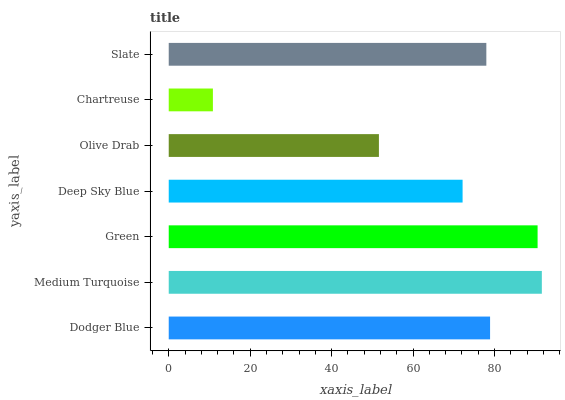Is Chartreuse the minimum?
Answer yes or no. Yes. Is Medium Turquoise the maximum?
Answer yes or no. Yes. Is Green the minimum?
Answer yes or no. No. Is Green the maximum?
Answer yes or no. No. Is Medium Turquoise greater than Green?
Answer yes or no. Yes. Is Green less than Medium Turquoise?
Answer yes or no. Yes. Is Green greater than Medium Turquoise?
Answer yes or no. No. Is Medium Turquoise less than Green?
Answer yes or no. No. Is Slate the high median?
Answer yes or no. Yes. Is Slate the low median?
Answer yes or no. Yes. Is Dodger Blue the high median?
Answer yes or no. No. Is Dodger Blue the low median?
Answer yes or no. No. 